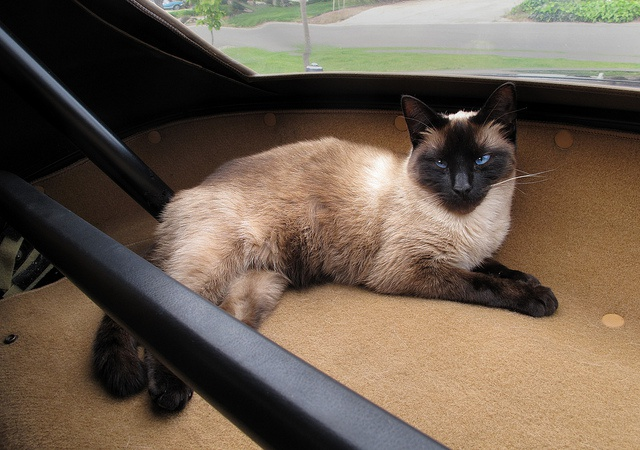Describe the objects in this image and their specific colors. I can see cat in black, tan, and gray tones and car in black, darkgray, lightgray, gray, and lightblue tones in this image. 